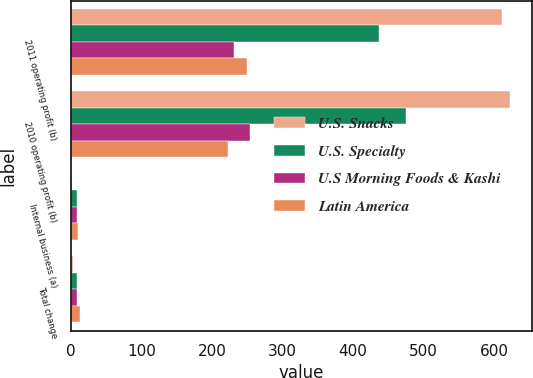Convert chart to OTSL. <chart><loc_0><loc_0><loc_500><loc_500><stacked_bar_chart><ecel><fcel>2011 operating profit (b)<fcel>2010 operating profit (b)<fcel>Internal business (a)<fcel>Total change<nl><fcel>U.S. Snacks<fcel>611<fcel>622<fcel>1.6<fcel>1.8<nl><fcel>U.S. Specialty<fcel>437<fcel>475<fcel>8.1<fcel>8.1<nl><fcel>U.S Morning Foods & Kashi<fcel>231<fcel>253<fcel>8.7<fcel>8.7<nl><fcel>Latin America<fcel>250<fcel>222<fcel>9.5<fcel>12.9<nl></chart> 